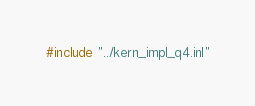<code> <loc_0><loc_0><loc_500><loc_500><_Cuda_>#include "../kern_impl_q4.inl"
</code> 